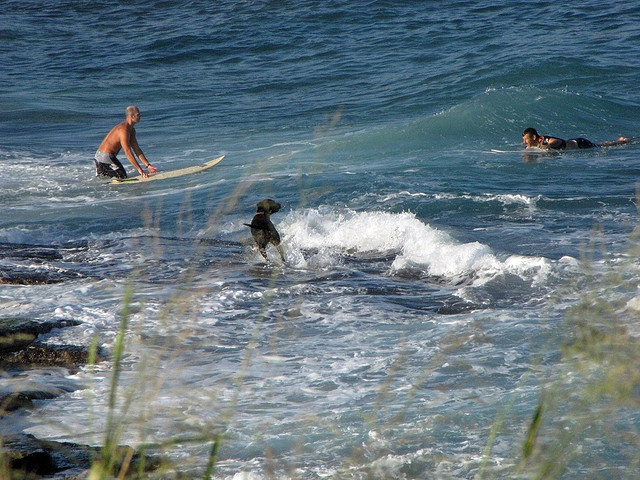Describe the objects in this image and their specific colors. I can see people in navy, black, salmon, brown, and maroon tones, dog in navy, black, gray, and darkgray tones, surfboard in navy, darkgray, gray, and tan tones, people in navy, black, gray, maroon, and blue tones, and surfboard in navy, gray, darkgray, and teal tones in this image. 